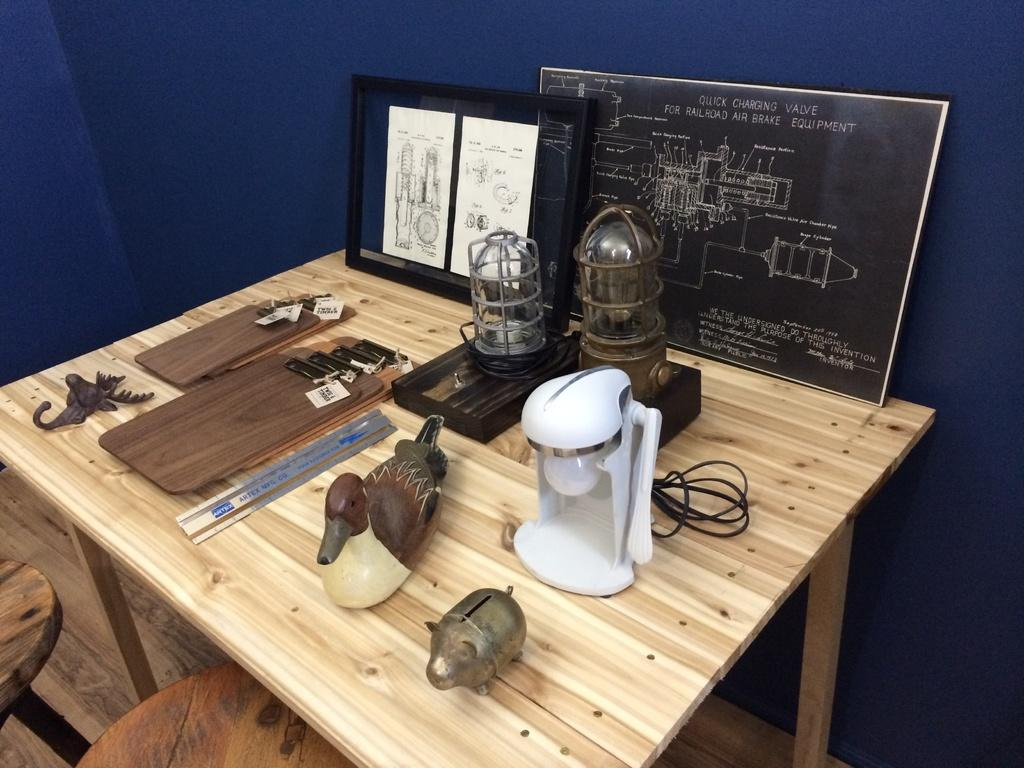What type of material is used for the items on the table? The wooden items on the table are made of wood. How many boards are on the table? There are two boards on the table. What is the table made of? The table is made of wood. What are the chairs made of? The chairs are made of wood. What type of current is flowing through the wooden items in the image? There is no indication of any current flowing through the wooden items in the image. 